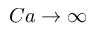Convert formula to latex. <formula><loc_0><loc_0><loc_500><loc_500>C a \rightarrow \infty</formula> 